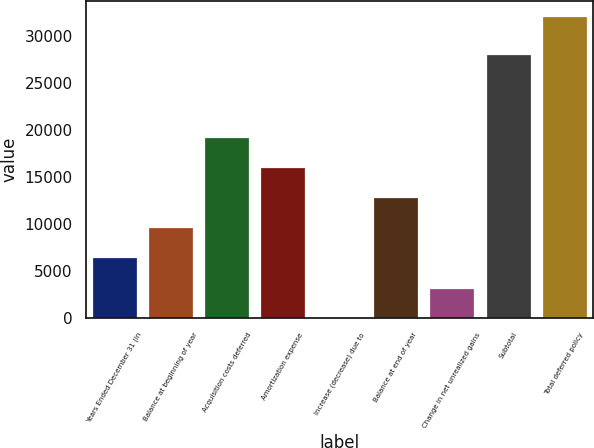Convert chart. <chart><loc_0><loc_0><loc_500><loc_500><bar_chart><fcel>Years Ended December 31 (in<fcel>Balance at beginning of year<fcel>Acquisition costs deferred<fcel>Amortization expense<fcel>Increase (decrease) due to<fcel>Balance at end of year<fcel>Change in net unrealized gains<fcel>Subtotal<fcel>Total deferred policy<nl><fcel>6482.8<fcel>9691.7<fcel>19318.4<fcel>16109.5<fcel>65<fcel>12900.6<fcel>3273.9<fcel>28106<fcel>32154<nl></chart> 